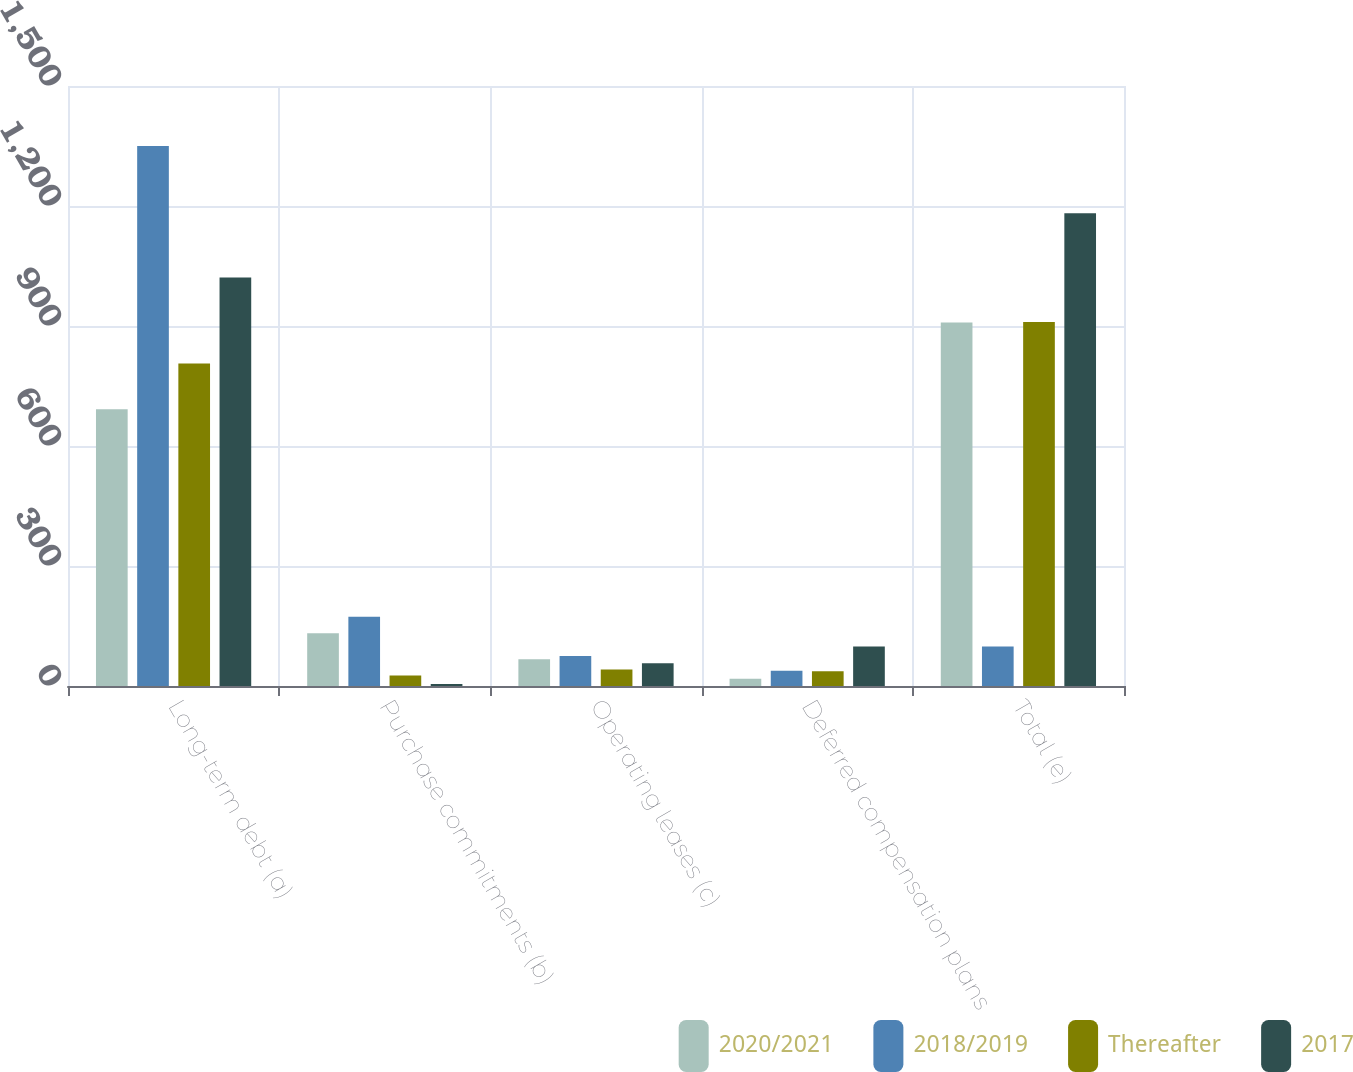Convert chart to OTSL. <chart><loc_0><loc_0><loc_500><loc_500><stacked_bar_chart><ecel><fcel>Long-term debt (a)<fcel>Purchase commitments (b)<fcel>Operating leases (c)<fcel>Deferred compensation plans<fcel>Total (e)<nl><fcel>2020/2021<fcel>692<fcel>132<fcel>67<fcel>18<fcel>909<nl><fcel>2018/2019<fcel>1350<fcel>173<fcel>75<fcel>38<fcel>99<nl><fcel>Thereafter<fcel>806<fcel>26<fcel>41<fcel>37<fcel>910<nl><fcel>2017<fcel>1021<fcel>5<fcel>57<fcel>99<fcel>1182<nl></chart> 